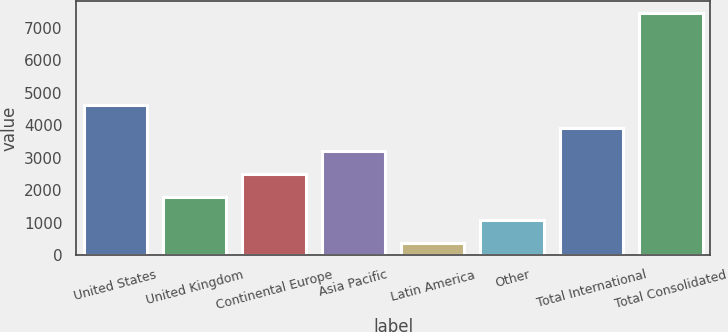Convert chart. <chart><loc_0><loc_0><loc_500><loc_500><bar_chart><fcel>United States<fcel>United Kingdom<fcel>Continental Europe<fcel>Asia Pacific<fcel>Latin America<fcel>Other<fcel>Total International<fcel>Total Consolidated<nl><fcel>4618.5<fcel>1784.7<fcel>2493.15<fcel>3201.6<fcel>367.8<fcel>1076.25<fcel>3910.05<fcel>7452.3<nl></chart> 